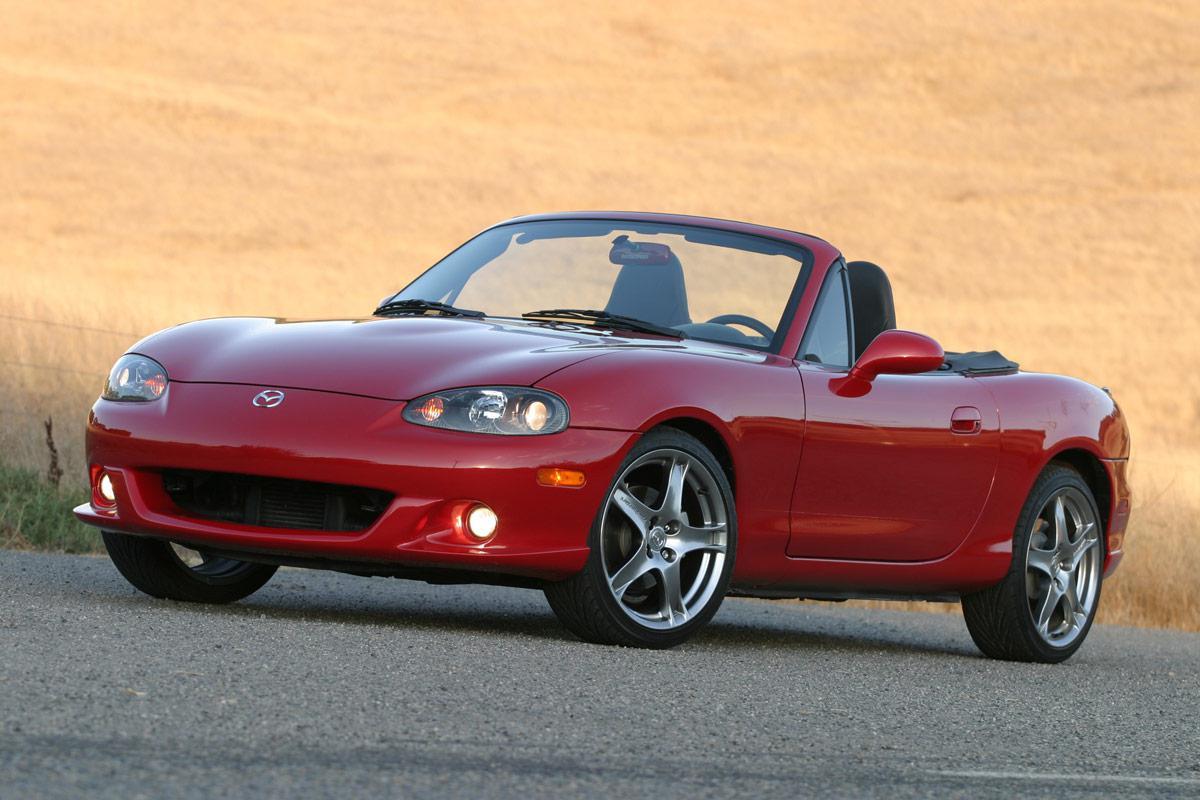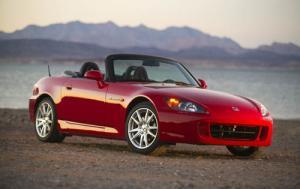The first image is the image on the left, the second image is the image on the right. Assess this claim about the two images: "There is a blue car facing right in the right image.". Correct or not? Answer yes or no. No. The first image is the image on the left, the second image is the image on the right. For the images displayed, is the sentence "There Is a single apple red car with the top down and thin tires facing left on the road." factually correct? Answer yes or no. Yes. 